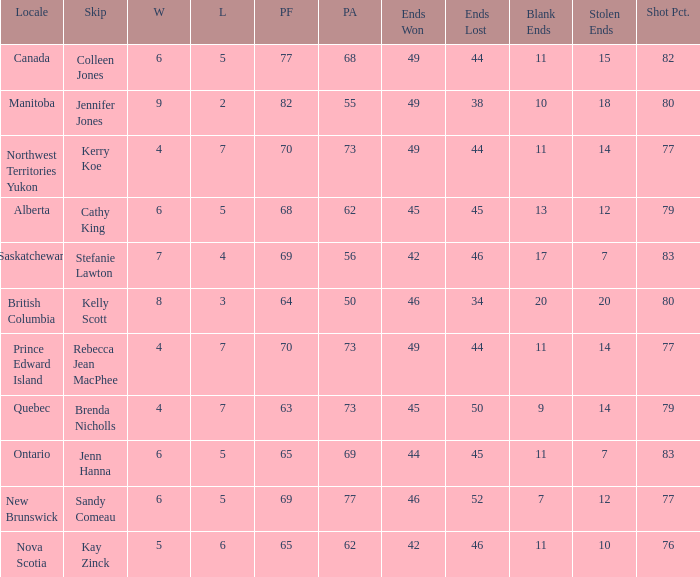What is the PA when the PF is 77? 68.0. 